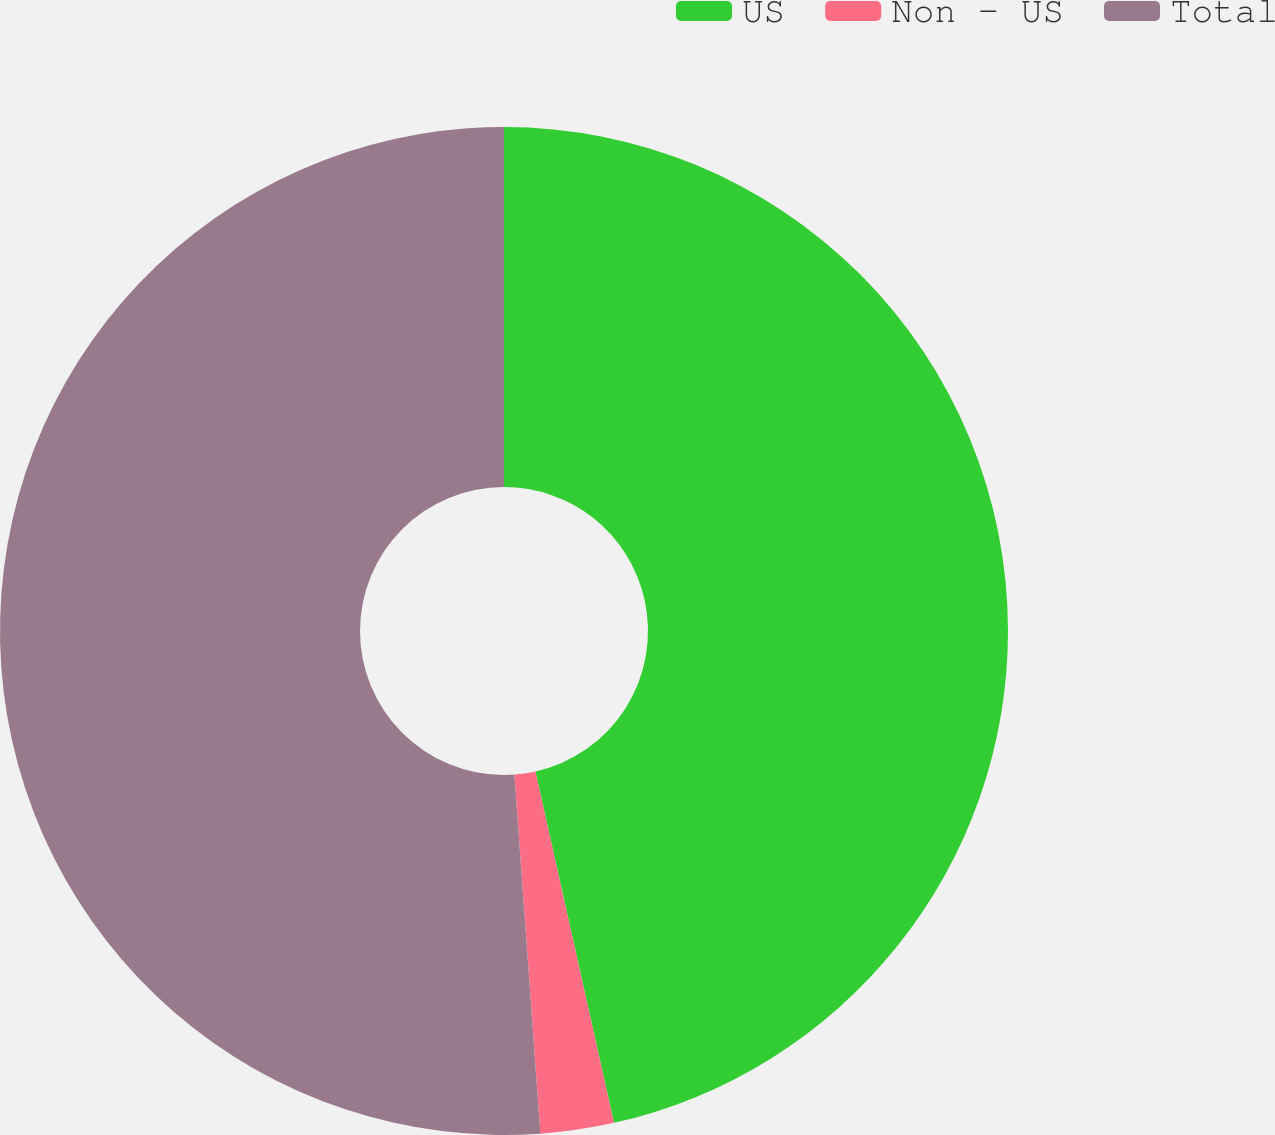Convert chart to OTSL. <chart><loc_0><loc_0><loc_500><loc_500><pie_chart><fcel>US<fcel>Non - US<fcel>Total<nl><fcel>46.5%<fcel>2.35%<fcel>51.15%<nl></chart> 